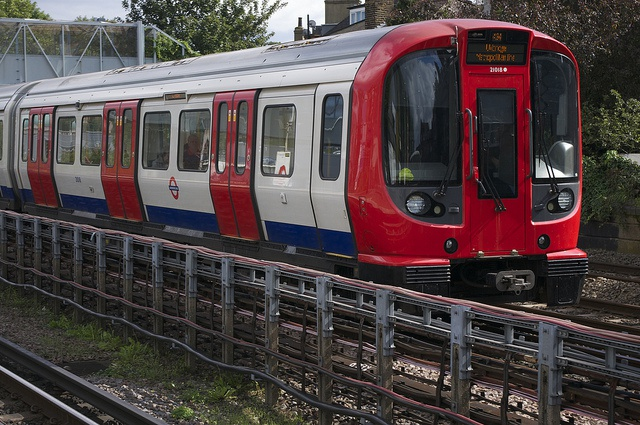Describe the objects in this image and their specific colors. I can see a train in darkgreen, black, darkgray, gray, and brown tones in this image. 